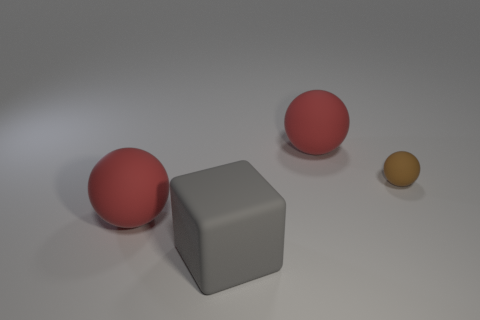Is there anything else that has the same shape as the gray object?
Give a very brief answer. No. Is the number of large spheres that are in front of the brown rubber thing greater than the number of gray matte objects that are in front of the large gray cube?
Offer a terse response. Yes. Are there any big things of the same shape as the tiny thing?
Give a very brief answer. Yes. There is a object that is on the right side of the sphere that is behind the brown rubber object; what is its size?
Give a very brief answer. Small. What shape is the thing right of the large red thing that is to the right of the red rubber ball to the left of the matte cube?
Offer a terse response. Sphere. There is a gray object that is made of the same material as the small brown thing; what is its size?
Give a very brief answer. Large. Is the number of big purple matte cubes greater than the number of large objects?
Ensure brevity in your answer.  No. There is a red ball in front of the brown matte sphere; is it the same size as the gray thing?
Provide a short and direct response. Yes. What number of cubes are big gray matte things or brown rubber objects?
Ensure brevity in your answer.  1. Is the number of large objects less than the number of objects?
Ensure brevity in your answer.  Yes. 